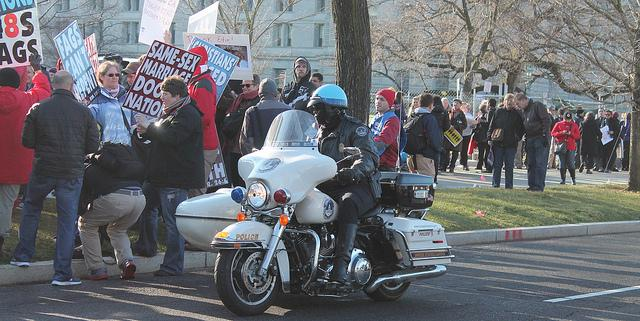What sort of sex is everyone here thinking about?

Choices:
A) straight
B) gay
C) bondage only
D) none gay 